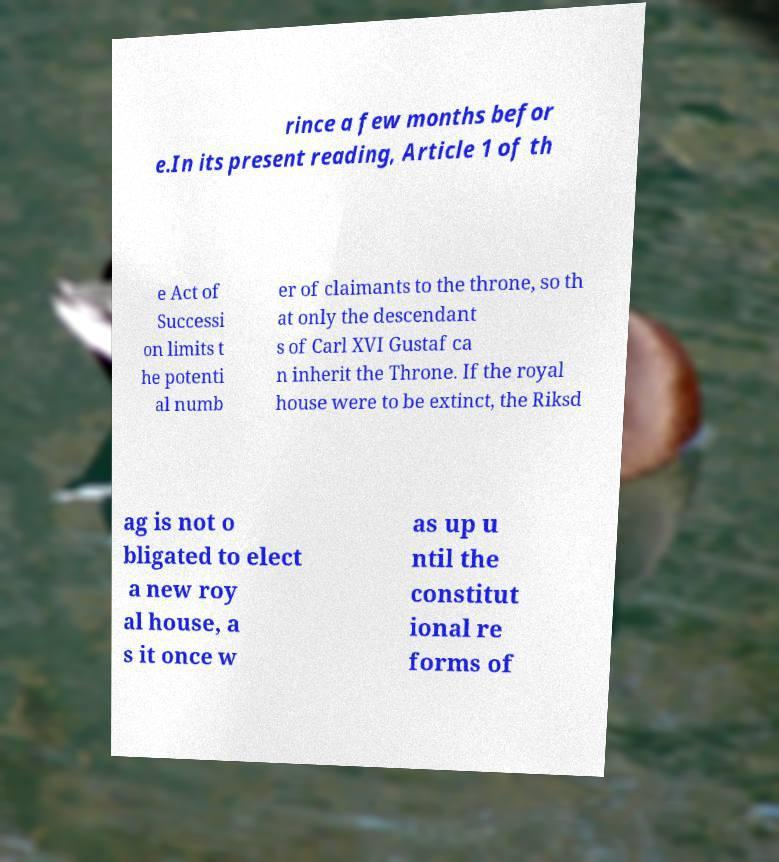There's text embedded in this image that I need extracted. Can you transcribe it verbatim? rince a few months befor e.In its present reading, Article 1 of th e Act of Successi on limits t he potenti al numb er of claimants to the throne, so th at only the descendant s of Carl XVI Gustaf ca n inherit the Throne. If the royal house were to be extinct, the Riksd ag is not o bligated to elect a new roy al house, a s it once w as up u ntil the constitut ional re forms of 